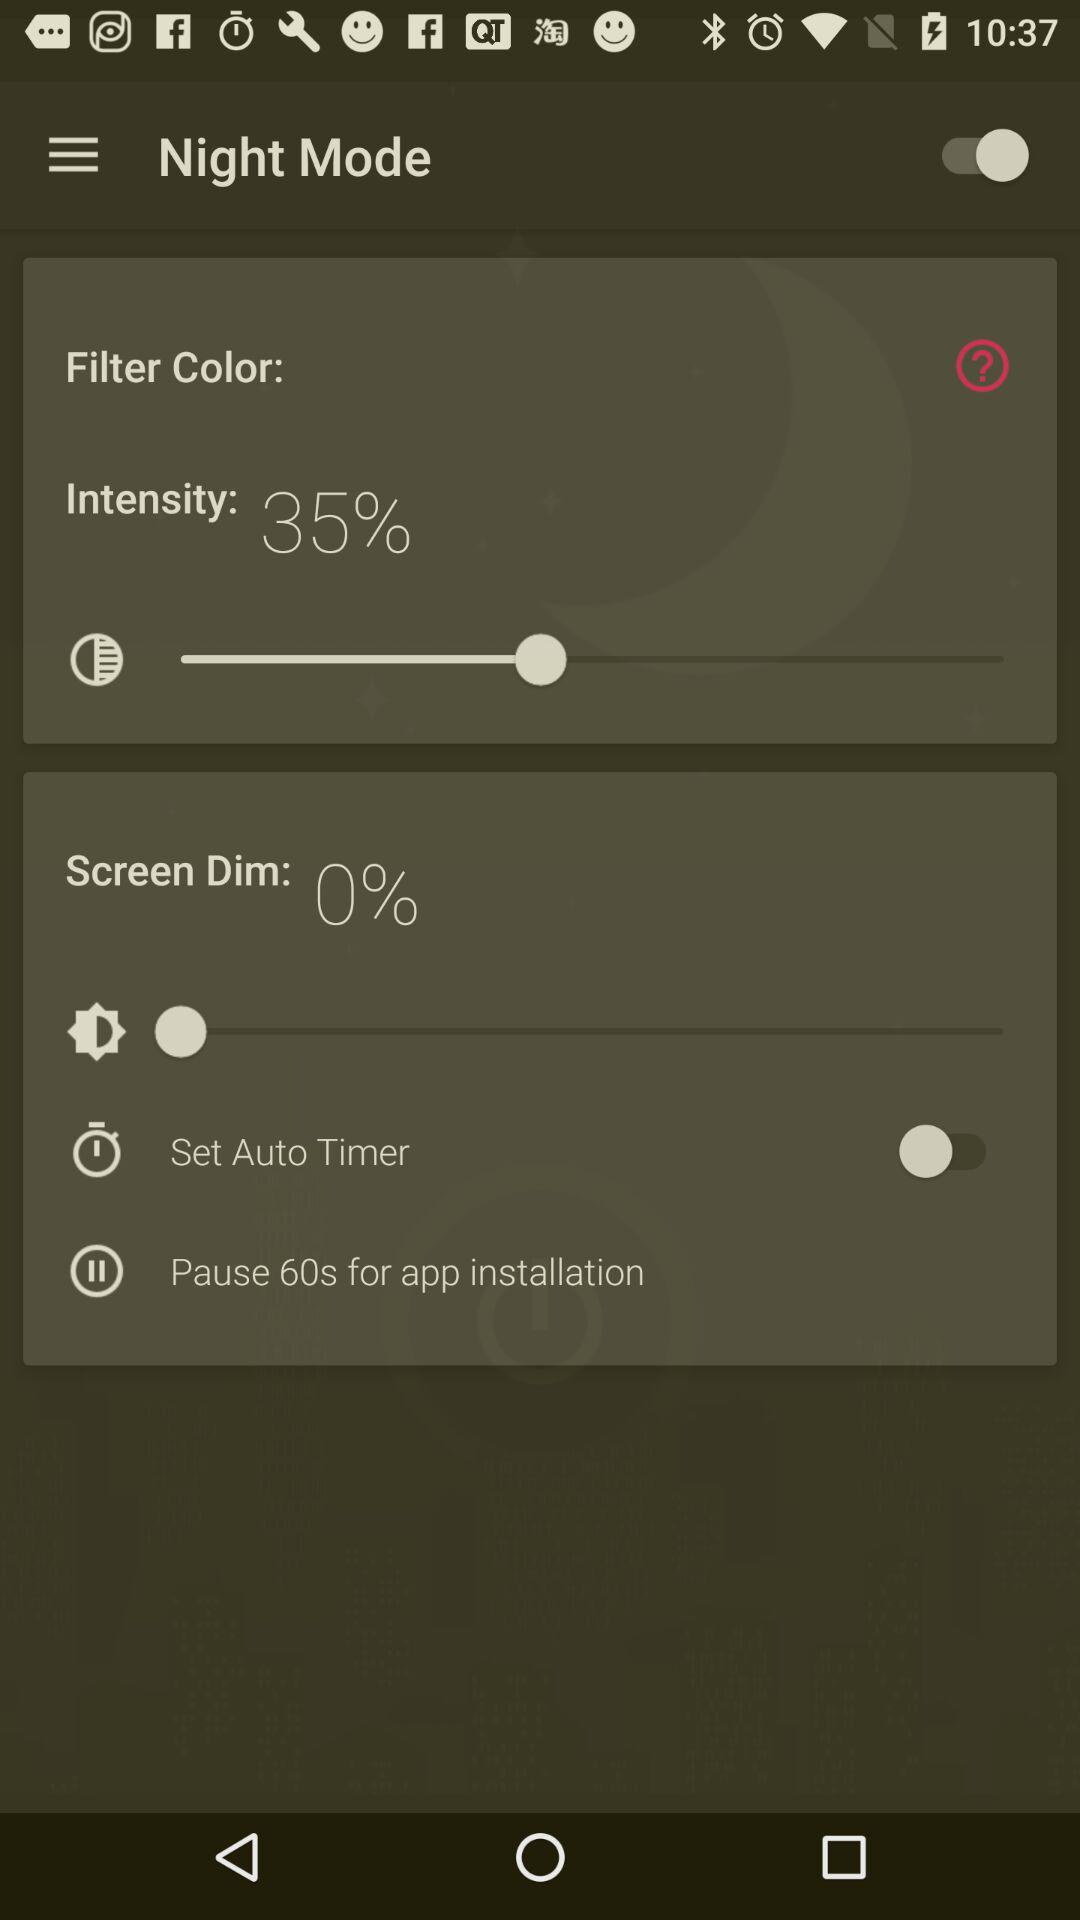How to set auto timer for night Mode?
When the provided information is insufficient, respond with <no answer>. <no answer> 